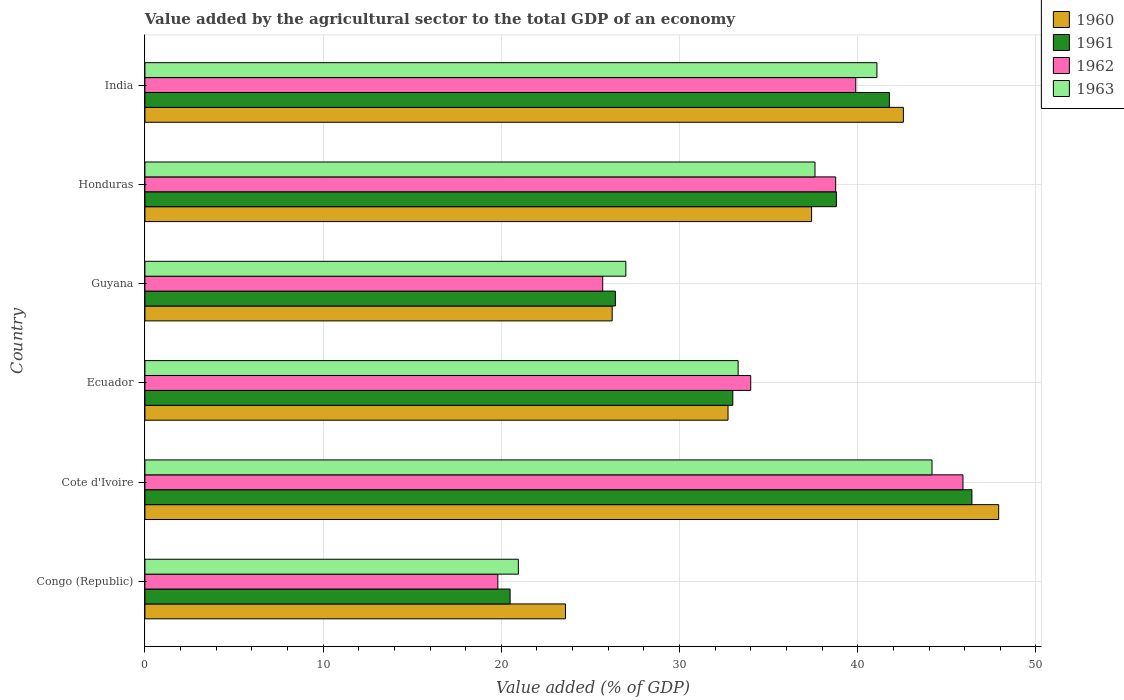How many groups of bars are there?
Your answer should be compact. 6. Are the number of bars per tick equal to the number of legend labels?
Offer a terse response. Yes. Are the number of bars on each tick of the Y-axis equal?
Ensure brevity in your answer.  Yes. How many bars are there on the 5th tick from the top?
Make the answer very short. 4. What is the label of the 4th group of bars from the top?
Your response must be concise. Ecuador. In how many cases, is the number of bars for a given country not equal to the number of legend labels?
Your answer should be compact. 0. What is the value added by the agricultural sector to the total GDP in 1962 in Guyana?
Your answer should be very brief. 25.69. Across all countries, what is the maximum value added by the agricultural sector to the total GDP in 1960?
Provide a succinct answer. 47.91. Across all countries, what is the minimum value added by the agricultural sector to the total GDP in 1961?
Make the answer very short. 20.49. In which country was the value added by the agricultural sector to the total GDP in 1960 maximum?
Make the answer very short. Cote d'Ivoire. In which country was the value added by the agricultural sector to the total GDP in 1960 minimum?
Give a very brief answer. Congo (Republic). What is the total value added by the agricultural sector to the total GDP in 1962 in the graph?
Your answer should be very brief. 204.04. What is the difference between the value added by the agricultural sector to the total GDP in 1962 in Cote d'Ivoire and that in Ecuador?
Ensure brevity in your answer.  11.91. What is the difference between the value added by the agricultural sector to the total GDP in 1960 in India and the value added by the agricultural sector to the total GDP in 1963 in Congo (Republic)?
Make the answer very short. 21.61. What is the average value added by the agricultural sector to the total GDP in 1963 per country?
Your answer should be compact. 34.01. What is the difference between the value added by the agricultural sector to the total GDP in 1960 and value added by the agricultural sector to the total GDP in 1963 in Honduras?
Give a very brief answer. -0.19. What is the ratio of the value added by the agricultural sector to the total GDP in 1962 in Cote d'Ivoire to that in Guyana?
Ensure brevity in your answer.  1.79. Is the value added by the agricultural sector to the total GDP in 1961 in Ecuador less than that in India?
Offer a terse response. Yes. Is the difference between the value added by the agricultural sector to the total GDP in 1960 in Guyana and Honduras greater than the difference between the value added by the agricultural sector to the total GDP in 1963 in Guyana and Honduras?
Ensure brevity in your answer.  No. What is the difference between the highest and the second highest value added by the agricultural sector to the total GDP in 1960?
Your answer should be very brief. 5.35. What is the difference between the highest and the lowest value added by the agricultural sector to the total GDP in 1960?
Ensure brevity in your answer.  24.31. In how many countries, is the value added by the agricultural sector to the total GDP in 1963 greater than the average value added by the agricultural sector to the total GDP in 1963 taken over all countries?
Your answer should be very brief. 3. Is it the case that in every country, the sum of the value added by the agricultural sector to the total GDP in 1960 and value added by the agricultural sector to the total GDP in 1962 is greater than the sum of value added by the agricultural sector to the total GDP in 1963 and value added by the agricultural sector to the total GDP in 1961?
Give a very brief answer. No. What does the 4th bar from the bottom in Guyana represents?
Your response must be concise. 1963. Is it the case that in every country, the sum of the value added by the agricultural sector to the total GDP in 1963 and value added by the agricultural sector to the total GDP in 1960 is greater than the value added by the agricultural sector to the total GDP in 1962?
Provide a succinct answer. Yes. Are all the bars in the graph horizontal?
Your response must be concise. Yes. How many countries are there in the graph?
Your answer should be compact. 6. What is the difference between two consecutive major ticks on the X-axis?
Ensure brevity in your answer.  10. Does the graph contain any zero values?
Your answer should be very brief. No. Does the graph contain grids?
Provide a succinct answer. Yes. Where does the legend appear in the graph?
Provide a succinct answer. Top right. What is the title of the graph?
Give a very brief answer. Value added by the agricultural sector to the total GDP of an economy. Does "1960" appear as one of the legend labels in the graph?
Keep it short and to the point. Yes. What is the label or title of the X-axis?
Give a very brief answer. Value added (% of GDP). What is the label or title of the Y-axis?
Provide a succinct answer. Country. What is the Value added (% of GDP) of 1960 in Congo (Republic)?
Provide a short and direct response. 23.6. What is the Value added (% of GDP) of 1961 in Congo (Republic)?
Make the answer very short. 20.49. What is the Value added (% of GDP) of 1962 in Congo (Republic)?
Your answer should be compact. 19.8. What is the Value added (% of GDP) in 1963 in Congo (Republic)?
Provide a succinct answer. 20.95. What is the Value added (% of GDP) of 1960 in Cote d'Ivoire?
Offer a very short reply. 47.91. What is the Value added (% of GDP) in 1961 in Cote d'Ivoire?
Offer a very short reply. 46.41. What is the Value added (% of GDP) in 1962 in Cote d'Ivoire?
Make the answer very short. 45.9. What is the Value added (% of GDP) in 1963 in Cote d'Ivoire?
Offer a terse response. 44.17. What is the Value added (% of GDP) in 1960 in Ecuador?
Your answer should be compact. 32.72. What is the Value added (% of GDP) in 1961 in Ecuador?
Your answer should be very brief. 32.99. What is the Value added (% of GDP) of 1962 in Ecuador?
Provide a short and direct response. 33.99. What is the Value added (% of GDP) of 1963 in Ecuador?
Keep it short and to the point. 33.29. What is the Value added (% of GDP) of 1960 in Guyana?
Ensure brevity in your answer.  26.22. What is the Value added (% of GDP) of 1961 in Guyana?
Offer a very short reply. 26.4. What is the Value added (% of GDP) in 1962 in Guyana?
Offer a terse response. 25.69. What is the Value added (% of GDP) in 1963 in Guyana?
Provide a succinct answer. 26.99. What is the Value added (% of GDP) in 1960 in Honduras?
Give a very brief answer. 37.41. What is the Value added (% of GDP) in 1961 in Honduras?
Provide a short and direct response. 38.8. What is the Value added (% of GDP) in 1962 in Honduras?
Give a very brief answer. 38.76. What is the Value added (% of GDP) of 1963 in Honduras?
Your answer should be very brief. 37.6. What is the Value added (% of GDP) of 1960 in India?
Make the answer very short. 42.56. What is the Value added (% of GDP) in 1961 in India?
Offer a terse response. 41.77. What is the Value added (% of GDP) of 1962 in India?
Offer a very short reply. 39.89. What is the Value added (% of GDP) of 1963 in India?
Make the answer very short. 41.08. Across all countries, what is the maximum Value added (% of GDP) of 1960?
Your answer should be very brief. 47.91. Across all countries, what is the maximum Value added (% of GDP) of 1961?
Your response must be concise. 46.41. Across all countries, what is the maximum Value added (% of GDP) in 1962?
Make the answer very short. 45.9. Across all countries, what is the maximum Value added (% of GDP) in 1963?
Provide a succinct answer. 44.17. Across all countries, what is the minimum Value added (% of GDP) in 1960?
Provide a short and direct response. 23.6. Across all countries, what is the minimum Value added (% of GDP) of 1961?
Ensure brevity in your answer.  20.49. Across all countries, what is the minimum Value added (% of GDP) of 1962?
Your response must be concise. 19.8. Across all countries, what is the minimum Value added (% of GDP) of 1963?
Your answer should be compact. 20.95. What is the total Value added (% of GDP) in 1960 in the graph?
Offer a very short reply. 210.42. What is the total Value added (% of GDP) of 1961 in the graph?
Your answer should be compact. 206.86. What is the total Value added (% of GDP) in 1962 in the graph?
Give a very brief answer. 204.04. What is the total Value added (% of GDP) of 1963 in the graph?
Offer a very short reply. 204.07. What is the difference between the Value added (% of GDP) in 1960 in Congo (Republic) and that in Cote d'Ivoire?
Your answer should be very brief. -24.31. What is the difference between the Value added (% of GDP) of 1961 in Congo (Republic) and that in Cote d'Ivoire?
Your answer should be very brief. -25.91. What is the difference between the Value added (% of GDP) of 1962 in Congo (Republic) and that in Cote d'Ivoire?
Ensure brevity in your answer.  -26.1. What is the difference between the Value added (% of GDP) of 1963 in Congo (Republic) and that in Cote d'Ivoire?
Your response must be concise. -23.21. What is the difference between the Value added (% of GDP) of 1960 in Congo (Republic) and that in Ecuador?
Your answer should be compact. -9.12. What is the difference between the Value added (% of GDP) of 1961 in Congo (Republic) and that in Ecuador?
Your answer should be very brief. -12.5. What is the difference between the Value added (% of GDP) in 1962 in Congo (Republic) and that in Ecuador?
Your answer should be compact. -14.19. What is the difference between the Value added (% of GDP) of 1963 in Congo (Republic) and that in Ecuador?
Your answer should be very brief. -12.33. What is the difference between the Value added (% of GDP) in 1960 in Congo (Republic) and that in Guyana?
Your answer should be very brief. -2.62. What is the difference between the Value added (% of GDP) of 1961 in Congo (Republic) and that in Guyana?
Make the answer very short. -5.91. What is the difference between the Value added (% of GDP) of 1962 in Congo (Republic) and that in Guyana?
Offer a terse response. -5.88. What is the difference between the Value added (% of GDP) in 1963 in Congo (Republic) and that in Guyana?
Offer a terse response. -6.03. What is the difference between the Value added (% of GDP) in 1960 in Congo (Republic) and that in Honduras?
Make the answer very short. -13.81. What is the difference between the Value added (% of GDP) of 1961 in Congo (Republic) and that in Honduras?
Your answer should be compact. -18.31. What is the difference between the Value added (% of GDP) of 1962 in Congo (Republic) and that in Honduras?
Make the answer very short. -18.96. What is the difference between the Value added (% of GDP) of 1963 in Congo (Republic) and that in Honduras?
Your answer should be very brief. -16.65. What is the difference between the Value added (% of GDP) of 1960 in Congo (Republic) and that in India?
Offer a very short reply. -18.96. What is the difference between the Value added (% of GDP) of 1961 in Congo (Republic) and that in India?
Provide a succinct answer. -21.28. What is the difference between the Value added (% of GDP) in 1962 in Congo (Republic) and that in India?
Your response must be concise. -20.08. What is the difference between the Value added (% of GDP) in 1963 in Congo (Republic) and that in India?
Offer a terse response. -20.12. What is the difference between the Value added (% of GDP) of 1960 in Cote d'Ivoire and that in Ecuador?
Offer a very short reply. 15.19. What is the difference between the Value added (% of GDP) of 1961 in Cote d'Ivoire and that in Ecuador?
Make the answer very short. 13.42. What is the difference between the Value added (% of GDP) in 1962 in Cote d'Ivoire and that in Ecuador?
Keep it short and to the point. 11.91. What is the difference between the Value added (% of GDP) of 1963 in Cote d'Ivoire and that in Ecuador?
Your response must be concise. 10.88. What is the difference between the Value added (% of GDP) in 1960 in Cote d'Ivoire and that in Guyana?
Give a very brief answer. 21.69. What is the difference between the Value added (% of GDP) in 1961 in Cote d'Ivoire and that in Guyana?
Make the answer very short. 20.01. What is the difference between the Value added (% of GDP) in 1962 in Cote d'Ivoire and that in Guyana?
Ensure brevity in your answer.  20.22. What is the difference between the Value added (% of GDP) in 1963 in Cote d'Ivoire and that in Guyana?
Your answer should be very brief. 17.18. What is the difference between the Value added (% of GDP) in 1960 in Cote d'Ivoire and that in Honduras?
Provide a short and direct response. 10.5. What is the difference between the Value added (% of GDP) of 1961 in Cote d'Ivoire and that in Honduras?
Keep it short and to the point. 7.61. What is the difference between the Value added (% of GDP) of 1962 in Cote d'Ivoire and that in Honduras?
Give a very brief answer. 7.14. What is the difference between the Value added (% of GDP) in 1963 in Cote d'Ivoire and that in Honduras?
Your response must be concise. 6.57. What is the difference between the Value added (% of GDP) in 1960 in Cote d'Ivoire and that in India?
Offer a very short reply. 5.35. What is the difference between the Value added (% of GDP) of 1961 in Cote d'Ivoire and that in India?
Your answer should be compact. 4.63. What is the difference between the Value added (% of GDP) of 1962 in Cote d'Ivoire and that in India?
Offer a terse response. 6.02. What is the difference between the Value added (% of GDP) in 1963 in Cote d'Ivoire and that in India?
Make the answer very short. 3.09. What is the difference between the Value added (% of GDP) of 1960 in Ecuador and that in Guyana?
Provide a short and direct response. 6.5. What is the difference between the Value added (% of GDP) of 1961 in Ecuador and that in Guyana?
Keep it short and to the point. 6.59. What is the difference between the Value added (% of GDP) of 1962 in Ecuador and that in Guyana?
Offer a very short reply. 8.31. What is the difference between the Value added (% of GDP) in 1963 in Ecuador and that in Guyana?
Keep it short and to the point. 6.3. What is the difference between the Value added (% of GDP) of 1960 in Ecuador and that in Honduras?
Offer a very short reply. -4.69. What is the difference between the Value added (% of GDP) of 1961 in Ecuador and that in Honduras?
Give a very brief answer. -5.81. What is the difference between the Value added (% of GDP) in 1962 in Ecuador and that in Honduras?
Your answer should be very brief. -4.77. What is the difference between the Value added (% of GDP) in 1963 in Ecuador and that in Honduras?
Provide a short and direct response. -4.31. What is the difference between the Value added (% of GDP) in 1960 in Ecuador and that in India?
Give a very brief answer. -9.84. What is the difference between the Value added (% of GDP) of 1961 in Ecuador and that in India?
Your answer should be very brief. -8.78. What is the difference between the Value added (% of GDP) of 1962 in Ecuador and that in India?
Offer a very short reply. -5.89. What is the difference between the Value added (% of GDP) of 1963 in Ecuador and that in India?
Offer a very short reply. -7.79. What is the difference between the Value added (% of GDP) in 1960 in Guyana and that in Honduras?
Provide a succinct answer. -11.19. What is the difference between the Value added (% of GDP) of 1961 in Guyana and that in Honduras?
Make the answer very short. -12.4. What is the difference between the Value added (% of GDP) in 1962 in Guyana and that in Honduras?
Offer a very short reply. -13.07. What is the difference between the Value added (% of GDP) of 1963 in Guyana and that in Honduras?
Give a very brief answer. -10.61. What is the difference between the Value added (% of GDP) in 1960 in Guyana and that in India?
Provide a short and direct response. -16.34. What is the difference between the Value added (% of GDP) of 1961 in Guyana and that in India?
Provide a succinct answer. -15.38. What is the difference between the Value added (% of GDP) of 1962 in Guyana and that in India?
Your answer should be compact. -14.2. What is the difference between the Value added (% of GDP) in 1963 in Guyana and that in India?
Ensure brevity in your answer.  -14.09. What is the difference between the Value added (% of GDP) in 1960 in Honduras and that in India?
Ensure brevity in your answer.  -5.15. What is the difference between the Value added (% of GDP) of 1961 in Honduras and that in India?
Your answer should be compact. -2.97. What is the difference between the Value added (% of GDP) in 1962 in Honduras and that in India?
Provide a short and direct response. -1.13. What is the difference between the Value added (% of GDP) of 1963 in Honduras and that in India?
Your response must be concise. -3.48. What is the difference between the Value added (% of GDP) of 1960 in Congo (Republic) and the Value added (% of GDP) of 1961 in Cote d'Ivoire?
Ensure brevity in your answer.  -22.81. What is the difference between the Value added (% of GDP) in 1960 in Congo (Republic) and the Value added (% of GDP) in 1962 in Cote d'Ivoire?
Make the answer very short. -22.3. What is the difference between the Value added (% of GDP) in 1960 in Congo (Republic) and the Value added (% of GDP) in 1963 in Cote d'Ivoire?
Your answer should be compact. -20.57. What is the difference between the Value added (% of GDP) in 1961 in Congo (Republic) and the Value added (% of GDP) in 1962 in Cote d'Ivoire?
Give a very brief answer. -25.41. What is the difference between the Value added (% of GDP) in 1961 in Congo (Republic) and the Value added (% of GDP) in 1963 in Cote d'Ivoire?
Ensure brevity in your answer.  -23.68. What is the difference between the Value added (% of GDP) of 1962 in Congo (Republic) and the Value added (% of GDP) of 1963 in Cote d'Ivoire?
Give a very brief answer. -24.36. What is the difference between the Value added (% of GDP) in 1960 in Congo (Republic) and the Value added (% of GDP) in 1961 in Ecuador?
Offer a terse response. -9.39. What is the difference between the Value added (% of GDP) of 1960 in Congo (Republic) and the Value added (% of GDP) of 1962 in Ecuador?
Your response must be concise. -10.39. What is the difference between the Value added (% of GDP) in 1960 in Congo (Republic) and the Value added (% of GDP) in 1963 in Ecuador?
Provide a succinct answer. -9.69. What is the difference between the Value added (% of GDP) in 1961 in Congo (Republic) and the Value added (% of GDP) in 1962 in Ecuador?
Your answer should be compact. -13.5. What is the difference between the Value added (% of GDP) of 1961 in Congo (Republic) and the Value added (% of GDP) of 1963 in Ecuador?
Your answer should be very brief. -12.8. What is the difference between the Value added (% of GDP) of 1962 in Congo (Republic) and the Value added (% of GDP) of 1963 in Ecuador?
Your answer should be very brief. -13.48. What is the difference between the Value added (% of GDP) of 1960 in Congo (Republic) and the Value added (% of GDP) of 1961 in Guyana?
Your answer should be compact. -2.8. What is the difference between the Value added (% of GDP) in 1960 in Congo (Republic) and the Value added (% of GDP) in 1962 in Guyana?
Offer a terse response. -2.09. What is the difference between the Value added (% of GDP) of 1960 in Congo (Republic) and the Value added (% of GDP) of 1963 in Guyana?
Keep it short and to the point. -3.39. What is the difference between the Value added (% of GDP) in 1961 in Congo (Republic) and the Value added (% of GDP) in 1962 in Guyana?
Make the answer very short. -5.2. What is the difference between the Value added (% of GDP) in 1961 in Congo (Republic) and the Value added (% of GDP) in 1963 in Guyana?
Provide a short and direct response. -6.49. What is the difference between the Value added (% of GDP) of 1962 in Congo (Republic) and the Value added (% of GDP) of 1963 in Guyana?
Ensure brevity in your answer.  -7.18. What is the difference between the Value added (% of GDP) of 1960 in Congo (Republic) and the Value added (% of GDP) of 1961 in Honduras?
Keep it short and to the point. -15.2. What is the difference between the Value added (% of GDP) in 1960 in Congo (Republic) and the Value added (% of GDP) in 1962 in Honduras?
Offer a terse response. -15.16. What is the difference between the Value added (% of GDP) in 1960 in Congo (Republic) and the Value added (% of GDP) in 1963 in Honduras?
Make the answer very short. -14. What is the difference between the Value added (% of GDP) of 1961 in Congo (Republic) and the Value added (% of GDP) of 1962 in Honduras?
Offer a terse response. -18.27. What is the difference between the Value added (% of GDP) of 1961 in Congo (Republic) and the Value added (% of GDP) of 1963 in Honduras?
Your answer should be compact. -17.11. What is the difference between the Value added (% of GDP) in 1962 in Congo (Republic) and the Value added (% of GDP) in 1963 in Honduras?
Provide a succinct answer. -17.8. What is the difference between the Value added (% of GDP) in 1960 in Congo (Republic) and the Value added (% of GDP) in 1961 in India?
Make the answer very short. -18.17. What is the difference between the Value added (% of GDP) of 1960 in Congo (Republic) and the Value added (% of GDP) of 1962 in India?
Provide a succinct answer. -16.29. What is the difference between the Value added (% of GDP) in 1960 in Congo (Republic) and the Value added (% of GDP) in 1963 in India?
Your answer should be very brief. -17.48. What is the difference between the Value added (% of GDP) in 1961 in Congo (Republic) and the Value added (% of GDP) in 1962 in India?
Your response must be concise. -19.4. What is the difference between the Value added (% of GDP) of 1961 in Congo (Republic) and the Value added (% of GDP) of 1963 in India?
Give a very brief answer. -20.58. What is the difference between the Value added (% of GDP) in 1962 in Congo (Republic) and the Value added (% of GDP) in 1963 in India?
Make the answer very short. -21.27. What is the difference between the Value added (% of GDP) of 1960 in Cote d'Ivoire and the Value added (% of GDP) of 1961 in Ecuador?
Your answer should be very brief. 14.92. What is the difference between the Value added (% of GDP) in 1960 in Cote d'Ivoire and the Value added (% of GDP) in 1962 in Ecuador?
Offer a terse response. 13.91. What is the difference between the Value added (% of GDP) of 1960 in Cote d'Ivoire and the Value added (% of GDP) of 1963 in Ecuador?
Your answer should be compact. 14.62. What is the difference between the Value added (% of GDP) of 1961 in Cote d'Ivoire and the Value added (% of GDP) of 1962 in Ecuador?
Your answer should be very brief. 12.41. What is the difference between the Value added (% of GDP) in 1961 in Cote d'Ivoire and the Value added (% of GDP) in 1963 in Ecuador?
Offer a very short reply. 13.12. What is the difference between the Value added (% of GDP) of 1962 in Cote d'Ivoire and the Value added (% of GDP) of 1963 in Ecuador?
Your answer should be very brief. 12.62. What is the difference between the Value added (% of GDP) in 1960 in Cote d'Ivoire and the Value added (% of GDP) in 1961 in Guyana?
Keep it short and to the point. 21.51. What is the difference between the Value added (% of GDP) of 1960 in Cote d'Ivoire and the Value added (% of GDP) of 1962 in Guyana?
Make the answer very short. 22.22. What is the difference between the Value added (% of GDP) in 1960 in Cote d'Ivoire and the Value added (% of GDP) in 1963 in Guyana?
Offer a terse response. 20.92. What is the difference between the Value added (% of GDP) of 1961 in Cote d'Ivoire and the Value added (% of GDP) of 1962 in Guyana?
Give a very brief answer. 20.72. What is the difference between the Value added (% of GDP) in 1961 in Cote d'Ivoire and the Value added (% of GDP) in 1963 in Guyana?
Your response must be concise. 19.42. What is the difference between the Value added (% of GDP) in 1962 in Cote d'Ivoire and the Value added (% of GDP) in 1963 in Guyana?
Keep it short and to the point. 18.92. What is the difference between the Value added (% of GDP) of 1960 in Cote d'Ivoire and the Value added (% of GDP) of 1961 in Honduras?
Provide a succinct answer. 9.11. What is the difference between the Value added (% of GDP) in 1960 in Cote d'Ivoire and the Value added (% of GDP) in 1962 in Honduras?
Your answer should be compact. 9.15. What is the difference between the Value added (% of GDP) of 1960 in Cote d'Ivoire and the Value added (% of GDP) of 1963 in Honduras?
Give a very brief answer. 10.31. What is the difference between the Value added (% of GDP) in 1961 in Cote d'Ivoire and the Value added (% of GDP) in 1962 in Honduras?
Make the answer very short. 7.65. What is the difference between the Value added (% of GDP) in 1961 in Cote d'Ivoire and the Value added (% of GDP) in 1963 in Honduras?
Offer a very short reply. 8.81. What is the difference between the Value added (% of GDP) in 1962 in Cote d'Ivoire and the Value added (% of GDP) in 1963 in Honduras?
Give a very brief answer. 8.3. What is the difference between the Value added (% of GDP) of 1960 in Cote d'Ivoire and the Value added (% of GDP) of 1961 in India?
Your response must be concise. 6.13. What is the difference between the Value added (% of GDP) in 1960 in Cote d'Ivoire and the Value added (% of GDP) in 1962 in India?
Make the answer very short. 8.02. What is the difference between the Value added (% of GDP) in 1960 in Cote d'Ivoire and the Value added (% of GDP) in 1963 in India?
Provide a succinct answer. 6.83. What is the difference between the Value added (% of GDP) in 1961 in Cote d'Ivoire and the Value added (% of GDP) in 1962 in India?
Your answer should be very brief. 6.52. What is the difference between the Value added (% of GDP) of 1961 in Cote d'Ivoire and the Value added (% of GDP) of 1963 in India?
Make the answer very short. 5.33. What is the difference between the Value added (% of GDP) in 1962 in Cote d'Ivoire and the Value added (% of GDP) in 1963 in India?
Your answer should be very brief. 4.83. What is the difference between the Value added (% of GDP) in 1960 in Ecuador and the Value added (% of GDP) in 1961 in Guyana?
Your answer should be compact. 6.32. What is the difference between the Value added (% of GDP) of 1960 in Ecuador and the Value added (% of GDP) of 1962 in Guyana?
Your answer should be very brief. 7.03. What is the difference between the Value added (% of GDP) of 1960 in Ecuador and the Value added (% of GDP) of 1963 in Guyana?
Give a very brief answer. 5.73. What is the difference between the Value added (% of GDP) in 1961 in Ecuador and the Value added (% of GDP) in 1962 in Guyana?
Ensure brevity in your answer.  7.3. What is the difference between the Value added (% of GDP) of 1961 in Ecuador and the Value added (% of GDP) of 1963 in Guyana?
Your response must be concise. 6. What is the difference between the Value added (% of GDP) in 1962 in Ecuador and the Value added (% of GDP) in 1963 in Guyana?
Offer a terse response. 7.01. What is the difference between the Value added (% of GDP) in 1960 in Ecuador and the Value added (% of GDP) in 1961 in Honduras?
Provide a succinct answer. -6.08. What is the difference between the Value added (% of GDP) of 1960 in Ecuador and the Value added (% of GDP) of 1962 in Honduras?
Your answer should be compact. -6.04. What is the difference between the Value added (% of GDP) in 1960 in Ecuador and the Value added (% of GDP) in 1963 in Honduras?
Keep it short and to the point. -4.88. What is the difference between the Value added (% of GDP) of 1961 in Ecuador and the Value added (% of GDP) of 1962 in Honduras?
Your response must be concise. -5.77. What is the difference between the Value added (% of GDP) of 1961 in Ecuador and the Value added (% of GDP) of 1963 in Honduras?
Your answer should be very brief. -4.61. What is the difference between the Value added (% of GDP) in 1962 in Ecuador and the Value added (% of GDP) in 1963 in Honduras?
Ensure brevity in your answer.  -3.61. What is the difference between the Value added (% of GDP) of 1960 in Ecuador and the Value added (% of GDP) of 1961 in India?
Give a very brief answer. -9.05. What is the difference between the Value added (% of GDP) in 1960 in Ecuador and the Value added (% of GDP) in 1962 in India?
Offer a terse response. -7.17. What is the difference between the Value added (% of GDP) in 1960 in Ecuador and the Value added (% of GDP) in 1963 in India?
Your answer should be compact. -8.36. What is the difference between the Value added (% of GDP) of 1961 in Ecuador and the Value added (% of GDP) of 1962 in India?
Provide a short and direct response. -6.9. What is the difference between the Value added (% of GDP) of 1961 in Ecuador and the Value added (% of GDP) of 1963 in India?
Provide a short and direct response. -8.09. What is the difference between the Value added (% of GDP) of 1962 in Ecuador and the Value added (% of GDP) of 1963 in India?
Your response must be concise. -7.08. What is the difference between the Value added (% of GDP) in 1960 in Guyana and the Value added (% of GDP) in 1961 in Honduras?
Ensure brevity in your answer.  -12.58. What is the difference between the Value added (% of GDP) in 1960 in Guyana and the Value added (% of GDP) in 1962 in Honduras?
Offer a very short reply. -12.54. What is the difference between the Value added (% of GDP) of 1960 in Guyana and the Value added (% of GDP) of 1963 in Honduras?
Give a very brief answer. -11.38. What is the difference between the Value added (% of GDP) in 1961 in Guyana and the Value added (% of GDP) in 1962 in Honduras?
Make the answer very short. -12.36. What is the difference between the Value added (% of GDP) in 1961 in Guyana and the Value added (% of GDP) in 1963 in Honduras?
Offer a terse response. -11.2. What is the difference between the Value added (% of GDP) in 1962 in Guyana and the Value added (% of GDP) in 1963 in Honduras?
Your answer should be compact. -11.91. What is the difference between the Value added (% of GDP) of 1960 in Guyana and the Value added (% of GDP) of 1961 in India?
Offer a terse response. -15.55. What is the difference between the Value added (% of GDP) of 1960 in Guyana and the Value added (% of GDP) of 1962 in India?
Give a very brief answer. -13.67. What is the difference between the Value added (% of GDP) in 1960 in Guyana and the Value added (% of GDP) in 1963 in India?
Keep it short and to the point. -14.86. What is the difference between the Value added (% of GDP) of 1961 in Guyana and the Value added (% of GDP) of 1962 in India?
Make the answer very short. -13.49. What is the difference between the Value added (% of GDP) in 1961 in Guyana and the Value added (% of GDP) in 1963 in India?
Provide a succinct answer. -14.68. What is the difference between the Value added (% of GDP) of 1962 in Guyana and the Value added (% of GDP) of 1963 in India?
Provide a short and direct response. -15.39. What is the difference between the Value added (% of GDP) in 1960 in Honduras and the Value added (% of GDP) in 1961 in India?
Your response must be concise. -4.36. What is the difference between the Value added (% of GDP) of 1960 in Honduras and the Value added (% of GDP) of 1962 in India?
Offer a very short reply. -2.48. What is the difference between the Value added (% of GDP) of 1960 in Honduras and the Value added (% of GDP) of 1963 in India?
Offer a very short reply. -3.67. What is the difference between the Value added (% of GDP) in 1961 in Honduras and the Value added (% of GDP) in 1962 in India?
Your answer should be very brief. -1.09. What is the difference between the Value added (% of GDP) of 1961 in Honduras and the Value added (% of GDP) of 1963 in India?
Offer a very short reply. -2.27. What is the difference between the Value added (% of GDP) of 1962 in Honduras and the Value added (% of GDP) of 1963 in India?
Give a very brief answer. -2.32. What is the average Value added (% of GDP) of 1960 per country?
Your response must be concise. 35.07. What is the average Value added (% of GDP) of 1961 per country?
Your answer should be very brief. 34.48. What is the average Value added (% of GDP) of 1962 per country?
Your response must be concise. 34.01. What is the average Value added (% of GDP) in 1963 per country?
Give a very brief answer. 34.01. What is the difference between the Value added (% of GDP) in 1960 and Value added (% of GDP) in 1961 in Congo (Republic)?
Provide a short and direct response. 3.11. What is the difference between the Value added (% of GDP) in 1960 and Value added (% of GDP) in 1962 in Congo (Republic)?
Your answer should be very brief. 3.8. What is the difference between the Value added (% of GDP) of 1960 and Value added (% of GDP) of 1963 in Congo (Republic)?
Your response must be concise. 2.65. What is the difference between the Value added (% of GDP) in 1961 and Value added (% of GDP) in 1962 in Congo (Republic)?
Make the answer very short. 0.69. What is the difference between the Value added (% of GDP) in 1961 and Value added (% of GDP) in 1963 in Congo (Republic)?
Ensure brevity in your answer.  -0.46. What is the difference between the Value added (% of GDP) of 1962 and Value added (% of GDP) of 1963 in Congo (Republic)?
Your answer should be very brief. -1.15. What is the difference between the Value added (% of GDP) of 1960 and Value added (% of GDP) of 1961 in Cote d'Ivoire?
Offer a very short reply. 1.5. What is the difference between the Value added (% of GDP) of 1960 and Value added (% of GDP) of 1962 in Cote d'Ivoire?
Give a very brief answer. 2. What is the difference between the Value added (% of GDP) in 1960 and Value added (% of GDP) in 1963 in Cote d'Ivoire?
Ensure brevity in your answer.  3.74. What is the difference between the Value added (% of GDP) of 1961 and Value added (% of GDP) of 1962 in Cote d'Ivoire?
Offer a terse response. 0.5. What is the difference between the Value added (% of GDP) of 1961 and Value added (% of GDP) of 1963 in Cote d'Ivoire?
Your response must be concise. 2.24. What is the difference between the Value added (% of GDP) in 1962 and Value added (% of GDP) in 1963 in Cote d'Ivoire?
Offer a very short reply. 1.74. What is the difference between the Value added (% of GDP) of 1960 and Value added (% of GDP) of 1961 in Ecuador?
Your answer should be very brief. -0.27. What is the difference between the Value added (% of GDP) in 1960 and Value added (% of GDP) in 1962 in Ecuador?
Offer a very short reply. -1.27. What is the difference between the Value added (% of GDP) of 1960 and Value added (% of GDP) of 1963 in Ecuador?
Offer a terse response. -0.57. What is the difference between the Value added (% of GDP) of 1961 and Value added (% of GDP) of 1962 in Ecuador?
Your response must be concise. -1. What is the difference between the Value added (% of GDP) in 1961 and Value added (% of GDP) in 1963 in Ecuador?
Ensure brevity in your answer.  -0.3. What is the difference between the Value added (% of GDP) of 1962 and Value added (% of GDP) of 1963 in Ecuador?
Offer a very short reply. 0.71. What is the difference between the Value added (% of GDP) of 1960 and Value added (% of GDP) of 1961 in Guyana?
Your answer should be compact. -0.18. What is the difference between the Value added (% of GDP) of 1960 and Value added (% of GDP) of 1962 in Guyana?
Make the answer very short. 0.53. What is the difference between the Value added (% of GDP) of 1960 and Value added (% of GDP) of 1963 in Guyana?
Make the answer very short. -0.77. What is the difference between the Value added (% of GDP) in 1961 and Value added (% of GDP) in 1962 in Guyana?
Keep it short and to the point. 0.71. What is the difference between the Value added (% of GDP) in 1961 and Value added (% of GDP) in 1963 in Guyana?
Keep it short and to the point. -0.59. What is the difference between the Value added (% of GDP) in 1962 and Value added (% of GDP) in 1963 in Guyana?
Offer a terse response. -1.3. What is the difference between the Value added (% of GDP) of 1960 and Value added (% of GDP) of 1961 in Honduras?
Keep it short and to the point. -1.39. What is the difference between the Value added (% of GDP) in 1960 and Value added (% of GDP) in 1962 in Honduras?
Your response must be concise. -1.35. What is the difference between the Value added (% of GDP) of 1960 and Value added (% of GDP) of 1963 in Honduras?
Give a very brief answer. -0.19. What is the difference between the Value added (% of GDP) of 1961 and Value added (% of GDP) of 1962 in Honduras?
Keep it short and to the point. 0.04. What is the difference between the Value added (% of GDP) of 1961 and Value added (% of GDP) of 1963 in Honduras?
Ensure brevity in your answer.  1.2. What is the difference between the Value added (% of GDP) in 1962 and Value added (% of GDP) in 1963 in Honduras?
Keep it short and to the point. 1.16. What is the difference between the Value added (% of GDP) of 1960 and Value added (% of GDP) of 1961 in India?
Offer a terse response. 0.79. What is the difference between the Value added (% of GDP) in 1960 and Value added (% of GDP) in 1962 in India?
Your response must be concise. 2.67. What is the difference between the Value added (% of GDP) in 1960 and Value added (% of GDP) in 1963 in India?
Provide a succinct answer. 1.49. What is the difference between the Value added (% of GDP) of 1961 and Value added (% of GDP) of 1962 in India?
Provide a succinct answer. 1.89. What is the difference between the Value added (% of GDP) of 1961 and Value added (% of GDP) of 1963 in India?
Your answer should be very brief. 0.7. What is the difference between the Value added (% of GDP) in 1962 and Value added (% of GDP) in 1963 in India?
Provide a succinct answer. -1.19. What is the ratio of the Value added (% of GDP) in 1960 in Congo (Republic) to that in Cote d'Ivoire?
Ensure brevity in your answer.  0.49. What is the ratio of the Value added (% of GDP) in 1961 in Congo (Republic) to that in Cote d'Ivoire?
Make the answer very short. 0.44. What is the ratio of the Value added (% of GDP) of 1962 in Congo (Republic) to that in Cote d'Ivoire?
Provide a short and direct response. 0.43. What is the ratio of the Value added (% of GDP) in 1963 in Congo (Republic) to that in Cote d'Ivoire?
Ensure brevity in your answer.  0.47. What is the ratio of the Value added (% of GDP) of 1960 in Congo (Republic) to that in Ecuador?
Provide a short and direct response. 0.72. What is the ratio of the Value added (% of GDP) in 1961 in Congo (Republic) to that in Ecuador?
Provide a succinct answer. 0.62. What is the ratio of the Value added (% of GDP) of 1962 in Congo (Republic) to that in Ecuador?
Ensure brevity in your answer.  0.58. What is the ratio of the Value added (% of GDP) in 1963 in Congo (Republic) to that in Ecuador?
Offer a terse response. 0.63. What is the ratio of the Value added (% of GDP) in 1960 in Congo (Republic) to that in Guyana?
Offer a very short reply. 0.9. What is the ratio of the Value added (% of GDP) of 1961 in Congo (Republic) to that in Guyana?
Your answer should be compact. 0.78. What is the ratio of the Value added (% of GDP) in 1962 in Congo (Republic) to that in Guyana?
Your response must be concise. 0.77. What is the ratio of the Value added (% of GDP) in 1963 in Congo (Republic) to that in Guyana?
Offer a terse response. 0.78. What is the ratio of the Value added (% of GDP) of 1960 in Congo (Republic) to that in Honduras?
Your answer should be compact. 0.63. What is the ratio of the Value added (% of GDP) of 1961 in Congo (Republic) to that in Honduras?
Make the answer very short. 0.53. What is the ratio of the Value added (% of GDP) in 1962 in Congo (Republic) to that in Honduras?
Ensure brevity in your answer.  0.51. What is the ratio of the Value added (% of GDP) in 1963 in Congo (Republic) to that in Honduras?
Your answer should be very brief. 0.56. What is the ratio of the Value added (% of GDP) in 1960 in Congo (Republic) to that in India?
Give a very brief answer. 0.55. What is the ratio of the Value added (% of GDP) in 1961 in Congo (Republic) to that in India?
Give a very brief answer. 0.49. What is the ratio of the Value added (% of GDP) of 1962 in Congo (Republic) to that in India?
Your answer should be compact. 0.5. What is the ratio of the Value added (% of GDP) of 1963 in Congo (Republic) to that in India?
Provide a short and direct response. 0.51. What is the ratio of the Value added (% of GDP) in 1960 in Cote d'Ivoire to that in Ecuador?
Offer a terse response. 1.46. What is the ratio of the Value added (% of GDP) in 1961 in Cote d'Ivoire to that in Ecuador?
Make the answer very short. 1.41. What is the ratio of the Value added (% of GDP) in 1962 in Cote d'Ivoire to that in Ecuador?
Provide a succinct answer. 1.35. What is the ratio of the Value added (% of GDP) in 1963 in Cote d'Ivoire to that in Ecuador?
Keep it short and to the point. 1.33. What is the ratio of the Value added (% of GDP) in 1960 in Cote d'Ivoire to that in Guyana?
Ensure brevity in your answer.  1.83. What is the ratio of the Value added (% of GDP) of 1961 in Cote d'Ivoire to that in Guyana?
Your answer should be compact. 1.76. What is the ratio of the Value added (% of GDP) in 1962 in Cote d'Ivoire to that in Guyana?
Provide a succinct answer. 1.79. What is the ratio of the Value added (% of GDP) in 1963 in Cote d'Ivoire to that in Guyana?
Your response must be concise. 1.64. What is the ratio of the Value added (% of GDP) of 1960 in Cote d'Ivoire to that in Honduras?
Offer a terse response. 1.28. What is the ratio of the Value added (% of GDP) in 1961 in Cote d'Ivoire to that in Honduras?
Make the answer very short. 1.2. What is the ratio of the Value added (% of GDP) of 1962 in Cote d'Ivoire to that in Honduras?
Offer a terse response. 1.18. What is the ratio of the Value added (% of GDP) of 1963 in Cote d'Ivoire to that in Honduras?
Keep it short and to the point. 1.17. What is the ratio of the Value added (% of GDP) of 1960 in Cote d'Ivoire to that in India?
Give a very brief answer. 1.13. What is the ratio of the Value added (% of GDP) in 1961 in Cote d'Ivoire to that in India?
Provide a succinct answer. 1.11. What is the ratio of the Value added (% of GDP) of 1962 in Cote d'Ivoire to that in India?
Your answer should be compact. 1.15. What is the ratio of the Value added (% of GDP) of 1963 in Cote d'Ivoire to that in India?
Give a very brief answer. 1.08. What is the ratio of the Value added (% of GDP) of 1960 in Ecuador to that in Guyana?
Offer a terse response. 1.25. What is the ratio of the Value added (% of GDP) in 1961 in Ecuador to that in Guyana?
Keep it short and to the point. 1.25. What is the ratio of the Value added (% of GDP) in 1962 in Ecuador to that in Guyana?
Give a very brief answer. 1.32. What is the ratio of the Value added (% of GDP) of 1963 in Ecuador to that in Guyana?
Provide a short and direct response. 1.23. What is the ratio of the Value added (% of GDP) in 1960 in Ecuador to that in Honduras?
Provide a succinct answer. 0.87. What is the ratio of the Value added (% of GDP) in 1961 in Ecuador to that in Honduras?
Your answer should be very brief. 0.85. What is the ratio of the Value added (% of GDP) of 1962 in Ecuador to that in Honduras?
Your response must be concise. 0.88. What is the ratio of the Value added (% of GDP) of 1963 in Ecuador to that in Honduras?
Keep it short and to the point. 0.89. What is the ratio of the Value added (% of GDP) in 1960 in Ecuador to that in India?
Make the answer very short. 0.77. What is the ratio of the Value added (% of GDP) in 1961 in Ecuador to that in India?
Offer a very short reply. 0.79. What is the ratio of the Value added (% of GDP) of 1962 in Ecuador to that in India?
Make the answer very short. 0.85. What is the ratio of the Value added (% of GDP) of 1963 in Ecuador to that in India?
Provide a short and direct response. 0.81. What is the ratio of the Value added (% of GDP) in 1960 in Guyana to that in Honduras?
Offer a very short reply. 0.7. What is the ratio of the Value added (% of GDP) of 1961 in Guyana to that in Honduras?
Give a very brief answer. 0.68. What is the ratio of the Value added (% of GDP) in 1962 in Guyana to that in Honduras?
Your response must be concise. 0.66. What is the ratio of the Value added (% of GDP) of 1963 in Guyana to that in Honduras?
Provide a succinct answer. 0.72. What is the ratio of the Value added (% of GDP) of 1960 in Guyana to that in India?
Your answer should be compact. 0.62. What is the ratio of the Value added (% of GDP) of 1961 in Guyana to that in India?
Keep it short and to the point. 0.63. What is the ratio of the Value added (% of GDP) of 1962 in Guyana to that in India?
Your answer should be very brief. 0.64. What is the ratio of the Value added (% of GDP) of 1963 in Guyana to that in India?
Provide a short and direct response. 0.66. What is the ratio of the Value added (% of GDP) of 1960 in Honduras to that in India?
Your answer should be compact. 0.88. What is the ratio of the Value added (% of GDP) in 1961 in Honduras to that in India?
Your response must be concise. 0.93. What is the ratio of the Value added (% of GDP) of 1962 in Honduras to that in India?
Your response must be concise. 0.97. What is the ratio of the Value added (% of GDP) of 1963 in Honduras to that in India?
Keep it short and to the point. 0.92. What is the difference between the highest and the second highest Value added (% of GDP) of 1960?
Provide a succinct answer. 5.35. What is the difference between the highest and the second highest Value added (% of GDP) of 1961?
Your answer should be very brief. 4.63. What is the difference between the highest and the second highest Value added (% of GDP) in 1962?
Your answer should be compact. 6.02. What is the difference between the highest and the second highest Value added (% of GDP) in 1963?
Ensure brevity in your answer.  3.09. What is the difference between the highest and the lowest Value added (% of GDP) of 1960?
Make the answer very short. 24.31. What is the difference between the highest and the lowest Value added (% of GDP) of 1961?
Offer a terse response. 25.91. What is the difference between the highest and the lowest Value added (% of GDP) in 1962?
Make the answer very short. 26.1. What is the difference between the highest and the lowest Value added (% of GDP) in 1963?
Your answer should be compact. 23.21. 